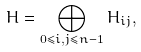Convert formula to latex. <formula><loc_0><loc_0><loc_500><loc_500>H = \bigoplus _ { 0 \leqslant i , j \leqslant n - 1 } H _ { i j } ,</formula> 